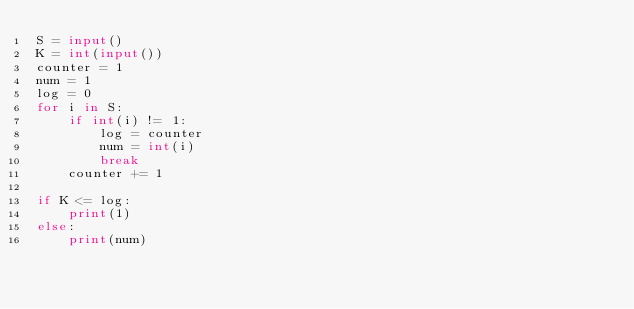Convert code to text. <code><loc_0><loc_0><loc_500><loc_500><_Python_>S = input()
K = int(input())
counter = 1
num = 1
log = 0
for i in S:
    if int(i) != 1:
        log = counter
        num = int(i)
        break
    counter += 1

if K <= log:
    print(1)
else:
    print(num)
</code> 